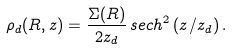Convert formula to latex. <formula><loc_0><loc_0><loc_500><loc_500>\rho _ { d } ( R , z ) = \frac { \Sigma ( R ) } { 2 z _ { d } } \, s e c h ^ { 2 } \, ( z / z _ { d } ) \, .</formula> 